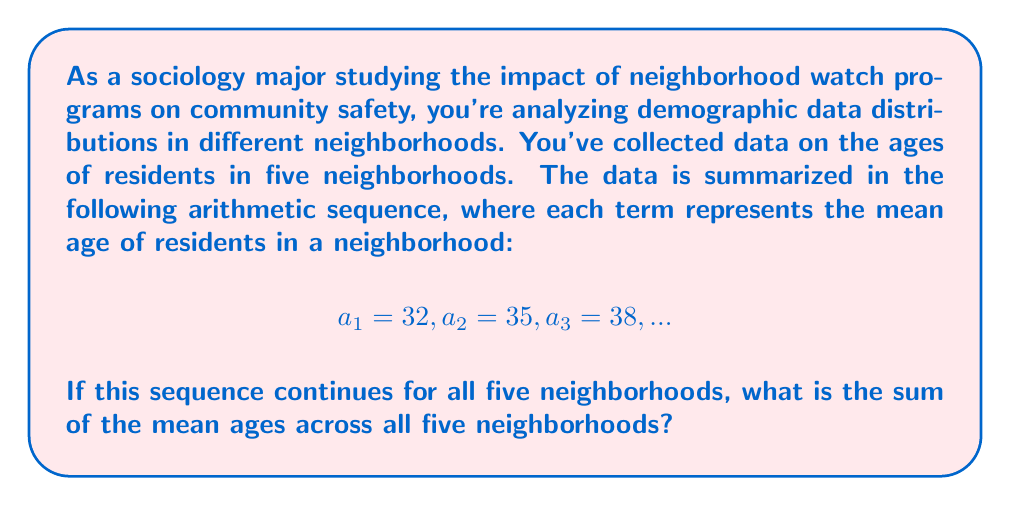Can you answer this question? To solve this problem, we need to follow these steps:

1) First, let's identify the components of the arithmetic sequence:
   - $a_1 = 32$ (first term)
   - The common difference, $d = a_2 - a_1 = 35 - 32 = 3$

2) We can verify this with $a_3$:
   $a_3 = a_2 + d = 35 + 3 = 38$, which matches the given information.

3) Now, we need to find the sum of 5 terms in this arithmetic sequence. We can use the formula for the sum of an arithmetic sequence:

   $S_n = \frac{n}{2}(a_1 + a_n)$

   Where:
   $S_n$ is the sum of $n$ terms
   $n$ is the number of terms (5 in this case)
   $a_1$ is the first term (32)
   $a_n$ is the last term (which we need to calculate)

4) To find $a_5$, we can use the formula for the nth term of an arithmetic sequence:
   $a_n = a_1 + (n-1)d$
   $a_5 = 32 + (5-1)3 = 32 + 12 = 44$

5) Now we can plug everything into our sum formula:

   $S_5 = \frac{5}{2}(32 + 44) = \frac{5}{2}(76) = 5(38) = 190$

Therefore, the sum of the mean ages across all five neighborhoods is 190.
Answer: 190 